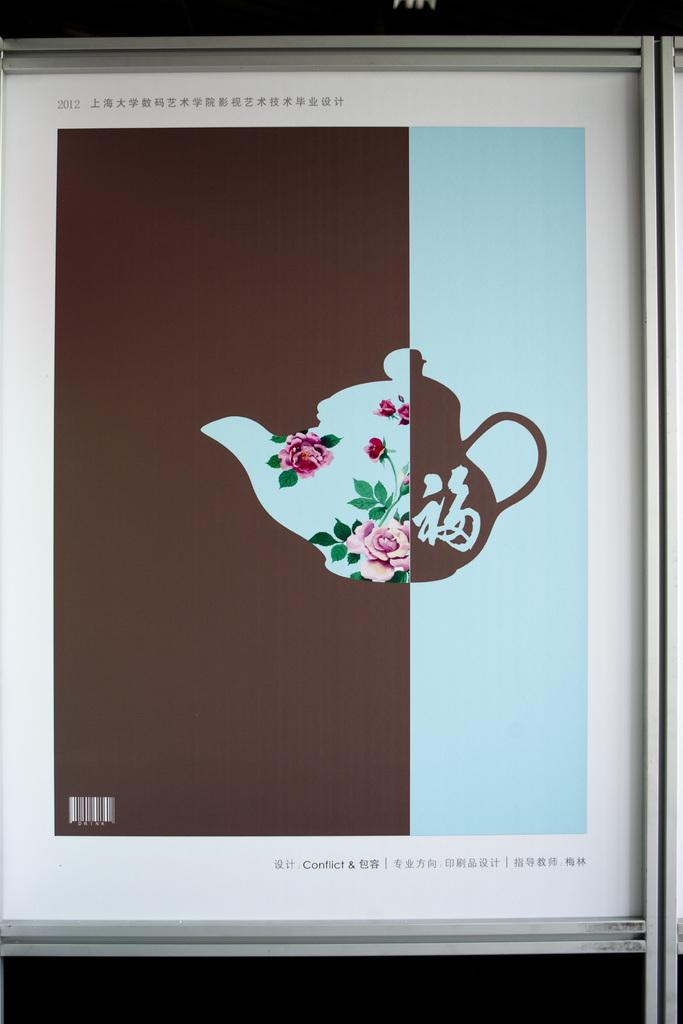<image>
Describe the image concisely. A picture of a teapot is shown to be from 2012. 